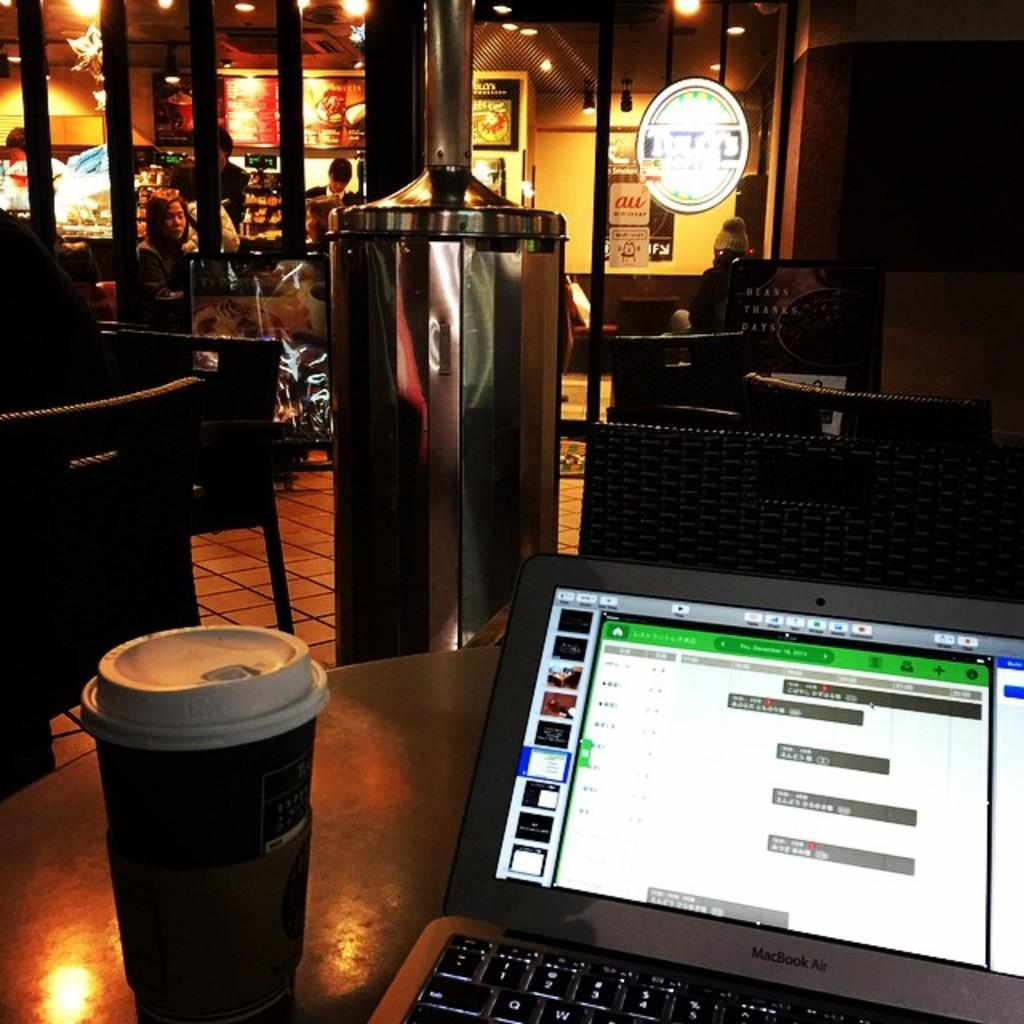<image>
Provide a brief description of the given image. A customer in a coffee shop sits a table works on his Macbook Air laptop 